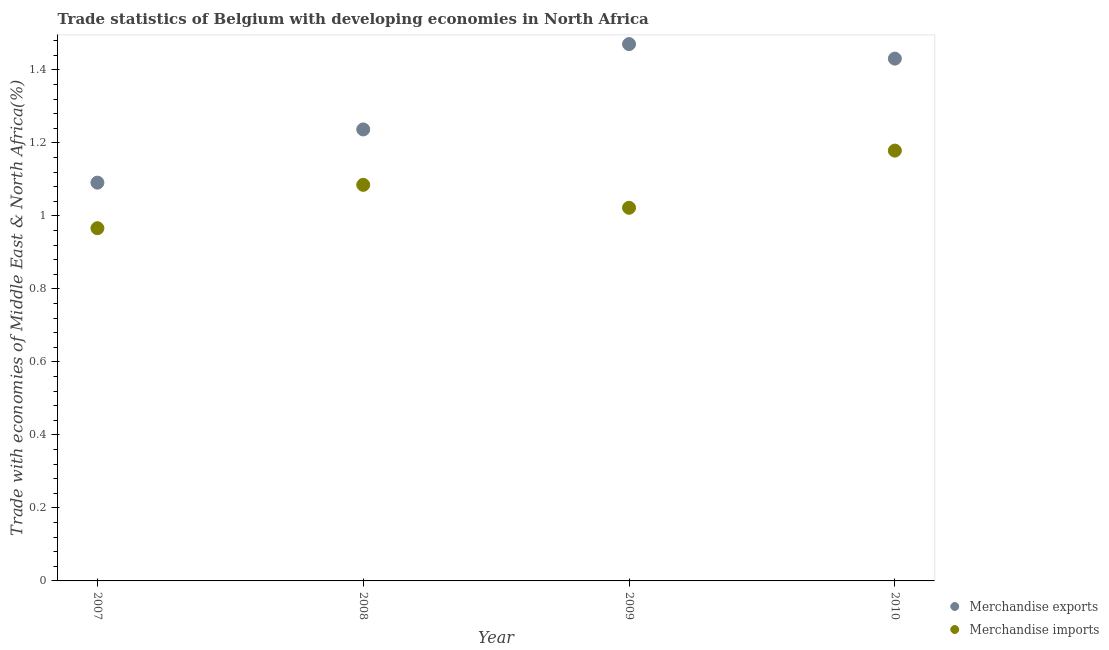How many different coloured dotlines are there?
Provide a succinct answer. 2. Is the number of dotlines equal to the number of legend labels?
Offer a very short reply. Yes. What is the merchandise exports in 2007?
Keep it short and to the point. 1.09. Across all years, what is the maximum merchandise exports?
Provide a succinct answer. 1.47. Across all years, what is the minimum merchandise exports?
Your answer should be compact. 1.09. What is the total merchandise imports in the graph?
Your response must be concise. 4.25. What is the difference between the merchandise exports in 2009 and that in 2010?
Give a very brief answer. 0.04. What is the difference between the merchandise imports in 2007 and the merchandise exports in 2009?
Offer a very short reply. -0.5. What is the average merchandise imports per year?
Offer a terse response. 1.06. In the year 2009, what is the difference between the merchandise imports and merchandise exports?
Ensure brevity in your answer.  -0.45. What is the ratio of the merchandise imports in 2007 to that in 2008?
Give a very brief answer. 0.89. Is the merchandise exports in 2007 less than that in 2009?
Ensure brevity in your answer.  Yes. What is the difference between the highest and the second highest merchandise exports?
Offer a very short reply. 0.04. What is the difference between the highest and the lowest merchandise exports?
Your response must be concise. 0.38. Is the merchandise imports strictly greater than the merchandise exports over the years?
Give a very brief answer. No. How many dotlines are there?
Your answer should be compact. 2. How many years are there in the graph?
Make the answer very short. 4. Does the graph contain any zero values?
Give a very brief answer. No. How are the legend labels stacked?
Provide a short and direct response. Vertical. What is the title of the graph?
Make the answer very short. Trade statistics of Belgium with developing economies in North Africa. Does "Depositors" appear as one of the legend labels in the graph?
Keep it short and to the point. No. What is the label or title of the X-axis?
Provide a succinct answer. Year. What is the label or title of the Y-axis?
Keep it short and to the point. Trade with economies of Middle East & North Africa(%). What is the Trade with economies of Middle East & North Africa(%) of Merchandise exports in 2007?
Keep it short and to the point. 1.09. What is the Trade with economies of Middle East & North Africa(%) of Merchandise imports in 2007?
Provide a succinct answer. 0.97. What is the Trade with economies of Middle East & North Africa(%) of Merchandise exports in 2008?
Your answer should be compact. 1.24. What is the Trade with economies of Middle East & North Africa(%) of Merchandise imports in 2008?
Offer a terse response. 1.09. What is the Trade with economies of Middle East & North Africa(%) in Merchandise exports in 2009?
Offer a very short reply. 1.47. What is the Trade with economies of Middle East & North Africa(%) in Merchandise imports in 2009?
Offer a very short reply. 1.02. What is the Trade with economies of Middle East & North Africa(%) in Merchandise exports in 2010?
Provide a short and direct response. 1.43. What is the Trade with economies of Middle East & North Africa(%) of Merchandise imports in 2010?
Provide a succinct answer. 1.18. Across all years, what is the maximum Trade with economies of Middle East & North Africa(%) of Merchandise exports?
Provide a succinct answer. 1.47. Across all years, what is the maximum Trade with economies of Middle East & North Africa(%) of Merchandise imports?
Your answer should be compact. 1.18. Across all years, what is the minimum Trade with economies of Middle East & North Africa(%) in Merchandise exports?
Your answer should be compact. 1.09. Across all years, what is the minimum Trade with economies of Middle East & North Africa(%) of Merchandise imports?
Offer a very short reply. 0.97. What is the total Trade with economies of Middle East & North Africa(%) of Merchandise exports in the graph?
Your answer should be compact. 5.23. What is the total Trade with economies of Middle East & North Africa(%) in Merchandise imports in the graph?
Offer a terse response. 4.25. What is the difference between the Trade with economies of Middle East & North Africa(%) of Merchandise exports in 2007 and that in 2008?
Your answer should be very brief. -0.15. What is the difference between the Trade with economies of Middle East & North Africa(%) in Merchandise imports in 2007 and that in 2008?
Give a very brief answer. -0.12. What is the difference between the Trade with economies of Middle East & North Africa(%) of Merchandise exports in 2007 and that in 2009?
Your answer should be compact. -0.38. What is the difference between the Trade with economies of Middle East & North Africa(%) of Merchandise imports in 2007 and that in 2009?
Keep it short and to the point. -0.06. What is the difference between the Trade with economies of Middle East & North Africa(%) of Merchandise exports in 2007 and that in 2010?
Offer a very short reply. -0.34. What is the difference between the Trade with economies of Middle East & North Africa(%) of Merchandise imports in 2007 and that in 2010?
Give a very brief answer. -0.21. What is the difference between the Trade with economies of Middle East & North Africa(%) of Merchandise exports in 2008 and that in 2009?
Your answer should be compact. -0.23. What is the difference between the Trade with economies of Middle East & North Africa(%) in Merchandise imports in 2008 and that in 2009?
Give a very brief answer. 0.06. What is the difference between the Trade with economies of Middle East & North Africa(%) of Merchandise exports in 2008 and that in 2010?
Offer a very short reply. -0.19. What is the difference between the Trade with economies of Middle East & North Africa(%) of Merchandise imports in 2008 and that in 2010?
Your answer should be compact. -0.09. What is the difference between the Trade with economies of Middle East & North Africa(%) in Merchandise exports in 2009 and that in 2010?
Give a very brief answer. 0.04. What is the difference between the Trade with economies of Middle East & North Africa(%) in Merchandise imports in 2009 and that in 2010?
Provide a succinct answer. -0.16. What is the difference between the Trade with economies of Middle East & North Africa(%) of Merchandise exports in 2007 and the Trade with economies of Middle East & North Africa(%) of Merchandise imports in 2008?
Make the answer very short. 0.01. What is the difference between the Trade with economies of Middle East & North Africa(%) in Merchandise exports in 2007 and the Trade with economies of Middle East & North Africa(%) in Merchandise imports in 2009?
Your answer should be compact. 0.07. What is the difference between the Trade with economies of Middle East & North Africa(%) of Merchandise exports in 2007 and the Trade with economies of Middle East & North Africa(%) of Merchandise imports in 2010?
Give a very brief answer. -0.09. What is the difference between the Trade with economies of Middle East & North Africa(%) of Merchandise exports in 2008 and the Trade with economies of Middle East & North Africa(%) of Merchandise imports in 2009?
Provide a succinct answer. 0.21. What is the difference between the Trade with economies of Middle East & North Africa(%) in Merchandise exports in 2008 and the Trade with economies of Middle East & North Africa(%) in Merchandise imports in 2010?
Ensure brevity in your answer.  0.06. What is the difference between the Trade with economies of Middle East & North Africa(%) in Merchandise exports in 2009 and the Trade with economies of Middle East & North Africa(%) in Merchandise imports in 2010?
Provide a short and direct response. 0.29. What is the average Trade with economies of Middle East & North Africa(%) in Merchandise exports per year?
Provide a short and direct response. 1.31. What is the average Trade with economies of Middle East & North Africa(%) of Merchandise imports per year?
Provide a short and direct response. 1.06. In the year 2007, what is the difference between the Trade with economies of Middle East & North Africa(%) in Merchandise exports and Trade with economies of Middle East & North Africa(%) in Merchandise imports?
Keep it short and to the point. 0.12. In the year 2008, what is the difference between the Trade with economies of Middle East & North Africa(%) of Merchandise exports and Trade with economies of Middle East & North Africa(%) of Merchandise imports?
Provide a succinct answer. 0.15. In the year 2009, what is the difference between the Trade with economies of Middle East & North Africa(%) of Merchandise exports and Trade with economies of Middle East & North Africa(%) of Merchandise imports?
Your answer should be very brief. 0.45. In the year 2010, what is the difference between the Trade with economies of Middle East & North Africa(%) in Merchandise exports and Trade with economies of Middle East & North Africa(%) in Merchandise imports?
Provide a short and direct response. 0.25. What is the ratio of the Trade with economies of Middle East & North Africa(%) in Merchandise exports in 2007 to that in 2008?
Give a very brief answer. 0.88. What is the ratio of the Trade with economies of Middle East & North Africa(%) in Merchandise imports in 2007 to that in 2008?
Provide a short and direct response. 0.89. What is the ratio of the Trade with economies of Middle East & North Africa(%) of Merchandise exports in 2007 to that in 2009?
Offer a terse response. 0.74. What is the ratio of the Trade with economies of Middle East & North Africa(%) of Merchandise imports in 2007 to that in 2009?
Your answer should be compact. 0.95. What is the ratio of the Trade with economies of Middle East & North Africa(%) in Merchandise exports in 2007 to that in 2010?
Ensure brevity in your answer.  0.76. What is the ratio of the Trade with economies of Middle East & North Africa(%) in Merchandise imports in 2007 to that in 2010?
Keep it short and to the point. 0.82. What is the ratio of the Trade with economies of Middle East & North Africa(%) of Merchandise exports in 2008 to that in 2009?
Ensure brevity in your answer.  0.84. What is the ratio of the Trade with economies of Middle East & North Africa(%) in Merchandise imports in 2008 to that in 2009?
Give a very brief answer. 1.06. What is the ratio of the Trade with economies of Middle East & North Africa(%) in Merchandise exports in 2008 to that in 2010?
Offer a very short reply. 0.86. What is the ratio of the Trade with economies of Middle East & North Africa(%) in Merchandise imports in 2008 to that in 2010?
Ensure brevity in your answer.  0.92. What is the ratio of the Trade with economies of Middle East & North Africa(%) in Merchandise exports in 2009 to that in 2010?
Your response must be concise. 1.03. What is the ratio of the Trade with economies of Middle East & North Africa(%) of Merchandise imports in 2009 to that in 2010?
Offer a terse response. 0.87. What is the difference between the highest and the second highest Trade with economies of Middle East & North Africa(%) of Merchandise exports?
Give a very brief answer. 0.04. What is the difference between the highest and the second highest Trade with economies of Middle East & North Africa(%) in Merchandise imports?
Make the answer very short. 0.09. What is the difference between the highest and the lowest Trade with economies of Middle East & North Africa(%) of Merchandise exports?
Your response must be concise. 0.38. What is the difference between the highest and the lowest Trade with economies of Middle East & North Africa(%) in Merchandise imports?
Provide a succinct answer. 0.21. 